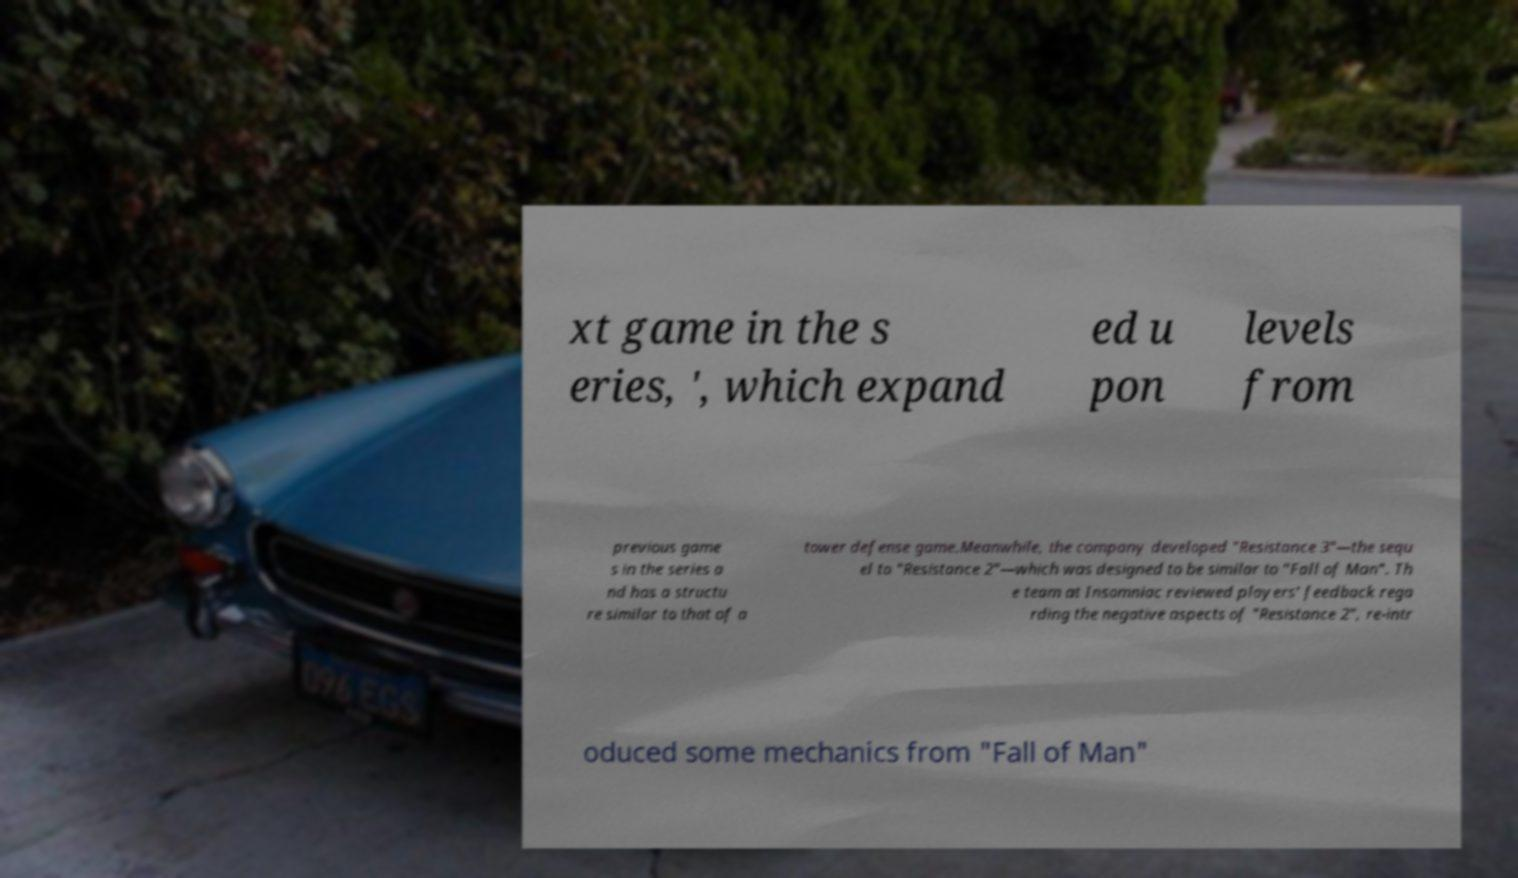I need the written content from this picture converted into text. Can you do that? xt game in the s eries, ', which expand ed u pon levels from previous game s in the series a nd has a structu re similar to that of a tower defense game.Meanwhile, the company developed "Resistance 3"—the sequ el to "Resistance 2"—which was designed to be similar to "Fall of Man". Th e team at Insomniac reviewed players' feedback rega rding the negative aspects of "Resistance 2", re-intr oduced some mechanics from "Fall of Man" 